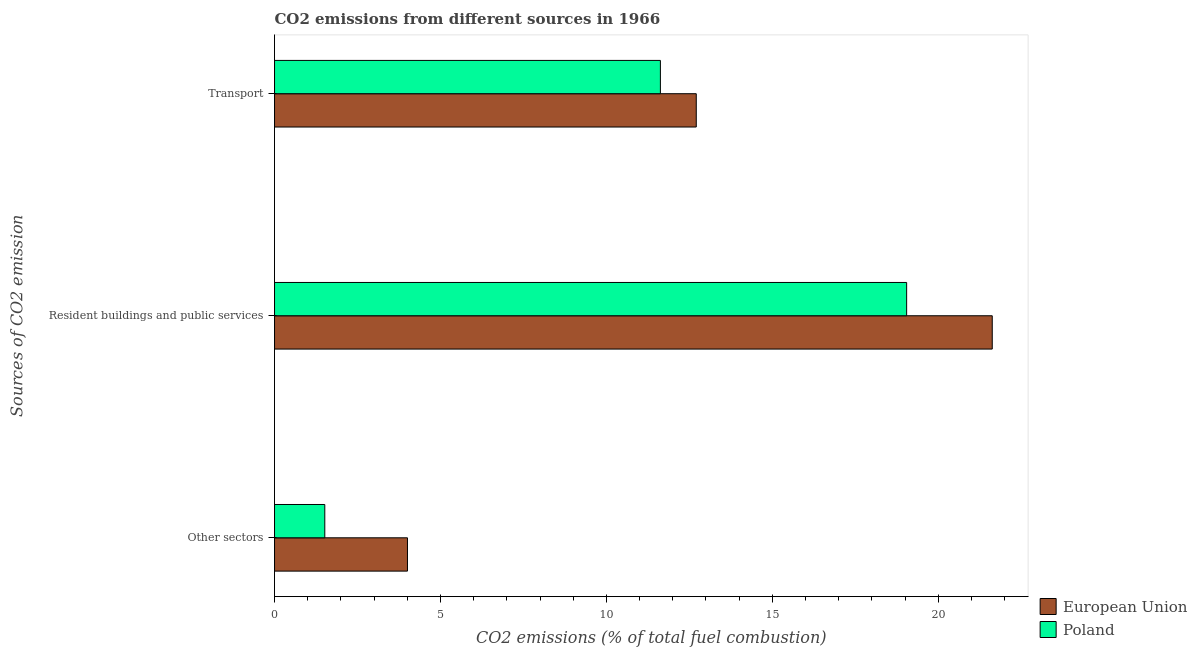How many different coloured bars are there?
Give a very brief answer. 2. Are the number of bars per tick equal to the number of legend labels?
Your response must be concise. Yes. Are the number of bars on each tick of the Y-axis equal?
Keep it short and to the point. Yes. What is the label of the 2nd group of bars from the top?
Your answer should be compact. Resident buildings and public services. What is the percentage of co2 emissions from resident buildings and public services in Poland?
Your answer should be compact. 19.05. Across all countries, what is the maximum percentage of co2 emissions from resident buildings and public services?
Make the answer very short. 21.63. Across all countries, what is the minimum percentage of co2 emissions from transport?
Offer a terse response. 11.63. In which country was the percentage of co2 emissions from transport minimum?
Your response must be concise. Poland. What is the total percentage of co2 emissions from resident buildings and public services in the graph?
Give a very brief answer. 40.67. What is the difference between the percentage of co2 emissions from other sectors in Poland and that in European Union?
Your answer should be very brief. -2.49. What is the difference between the percentage of co2 emissions from resident buildings and public services in Poland and the percentage of co2 emissions from transport in European Union?
Your response must be concise. 6.34. What is the average percentage of co2 emissions from other sectors per country?
Keep it short and to the point. 2.76. What is the difference between the percentage of co2 emissions from other sectors and percentage of co2 emissions from transport in European Union?
Provide a short and direct response. -8.7. In how many countries, is the percentage of co2 emissions from transport greater than 14 %?
Your response must be concise. 0. What is the ratio of the percentage of co2 emissions from other sectors in Poland to that in European Union?
Provide a short and direct response. 0.38. Is the percentage of co2 emissions from other sectors in European Union less than that in Poland?
Ensure brevity in your answer.  No. What is the difference between the highest and the second highest percentage of co2 emissions from other sectors?
Offer a very short reply. 2.49. What is the difference between the highest and the lowest percentage of co2 emissions from other sectors?
Offer a terse response. 2.49. Is the sum of the percentage of co2 emissions from resident buildings and public services in Poland and European Union greater than the maximum percentage of co2 emissions from other sectors across all countries?
Offer a terse response. Yes. What does the 1st bar from the top in Other sectors represents?
Provide a short and direct response. Poland. What does the 1st bar from the bottom in Resident buildings and public services represents?
Ensure brevity in your answer.  European Union. Are all the bars in the graph horizontal?
Provide a short and direct response. Yes. How many countries are there in the graph?
Keep it short and to the point. 2. Are the values on the major ticks of X-axis written in scientific E-notation?
Offer a terse response. No. Does the graph contain any zero values?
Your answer should be very brief. No. Does the graph contain grids?
Your answer should be very brief. No. How many legend labels are there?
Your response must be concise. 2. What is the title of the graph?
Offer a very short reply. CO2 emissions from different sources in 1966. Does "Czech Republic" appear as one of the legend labels in the graph?
Provide a succinct answer. No. What is the label or title of the X-axis?
Offer a very short reply. CO2 emissions (% of total fuel combustion). What is the label or title of the Y-axis?
Offer a very short reply. Sources of CO2 emission. What is the CO2 emissions (% of total fuel combustion) in European Union in Other sectors?
Provide a short and direct response. 4.01. What is the CO2 emissions (% of total fuel combustion) in Poland in Other sectors?
Offer a terse response. 1.51. What is the CO2 emissions (% of total fuel combustion) in European Union in Resident buildings and public services?
Keep it short and to the point. 21.63. What is the CO2 emissions (% of total fuel combustion) of Poland in Resident buildings and public services?
Your answer should be very brief. 19.05. What is the CO2 emissions (% of total fuel combustion) in European Union in Transport?
Your answer should be compact. 12.71. What is the CO2 emissions (% of total fuel combustion) in Poland in Transport?
Provide a short and direct response. 11.63. Across all Sources of CO2 emission, what is the maximum CO2 emissions (% of total fuel combustion) of European Union?
Give a very brief answer. 21.63. Across all Sources of CO2 emission, what is the maximum CO2 emissions (% of total fuel combustion) in Poland?
Provide a short and direct response. 19.05. Across all Sources of CO2 emission, what is the minimum CO2 emissions (% of total fuel combustion) of European Union?
Offer a terse response. 4.01. Across all Sources of CO2 emission, what is the minimum CO2 emissions (% of total fuel combustion) of Poland?
Provide a short and direct response. 1.51. What is the total CO2 emissions (% of total fuel combustion) in European Union in the graph?
Your answer should be very brief. 38.34. What is the total CO2 emissions (% of total fuel combustion) in Poland in the graph?
Your answer should be compact. 32.19. What is the difference between the CO2 emissions (% of total fuel combustion) in European Union in Other sectors and that in Resident buildings and public services?
Offer a terse response. -17.62. What is the difference between the CO2 emissions (% of total fuel combustion) of Poland in Other sectors and that in Resident buildings and public services?
Offer a terse response. -17.53. What is the difference between the CO2 emissions (% of total fuel combustion) in European Union in Other sectors and that in Transport?
Make the answer very short. -8.7. What is the difference between the CO2 emissions (% of total fuel combustion) of Poland in Other sectors and that in Transport?
Provide a short and direct response. -10.11. What is the difference between the CO2 emissions (% of total fuel combustion) of European Union in Resident buildings and public services and that in Transport?
Provide a short and direct response. 8.92. What is the difference between the CO2 emissions (% of total fuel combustion) of Poland in Resident buildings and public services and that in Transport?
Your answer should be compact. 7.42. What is the difference between the CO2 emissions (% of total fuel combustion) of European Union in Other sectors and the CO2 emissions (% of total fuel combustion) of Poland in Resident buildings and public services?
Offer a very short reply. -15.04. What is the difference between the CO2 emissions (% of total fuel combustion) in European Union in Other sectors and the CO2 emissions (% of total fuel combustion) in Poland in Transport?
Ensure brevity in your answer.  -7.62. What is the difference between the CO2 emissions (% of total fuel combustion) in European Union in Resident buildings and public services and the CO2 emissions (% of total fuel combustion) in Poland in Transport?
Keep it short and to the point. 10. What is the average CO2 emissions (% of total fuel combustion) in European Union per Sources of CO2 emission?
Ensure brevity in your answer.  12.78. What is the average CO2 emissions (% of total fuel combustion) of Poland per Sources of CO2 emission?
Make the answer very short. 10.73. What is the difference between the CO2 emissions (% of total fuel combustion) of European Union and CO2 emissions (% of total fuel combustion) of Poland in Other sectors?
Provide a succinct answer. 2.49. What is the difference between the CO2 emissions (% of total fuel combustion) of European Union and CO2 emissions (% of total fuel combustion) of Poland in Resident buildings and public services?
Your answer should be compact. 2.58. What is the difference between the CO2 emissions (% of total fuel combustion) of European Union and CO2 emissions (% of total fuel combustion) of Poland in Transport?
Your response must be concise. 1.08. What is the ratio of the CO2 emissions (% of total fuel combustion) of European Union in Other sectors to that in Resident buildings and public services?
Ensure brevity in your answer.  0.19. What is the ratio of the CO2 emissions (% of total fuel combustion) of Poland in Other sectors to that in Resident buildings and public services?
Keep it short and to the point. 0.08. What is the ratio of the CO2 emissions (% of total fuel combustion) of European Union in Other sectors to that in Transport?
Keep it short and to the point. 0.32. What is the ratio of the CO2 emissions (% of total fuel combustion) of Poland in Other sectors to that in Transport?
Keep it short and to the point. 0.13. What is the ratio of the CO2 emissions (% of total fuel combustion) of European Union in Resident buildings and public services to that in Transport?
Offer a terse response. 1.7. What is the ratio of the CO2 emissions (% of total fuel combustion) in Poland in Resident buildings and public services to that in Transport?
Provide a short and direct response. 1.64. What is the difference between the highest and the second highest CO2 emissions (% of total fuel combustion) in European Union?
Your answer should be compact. 8.92. What is the difference between the highest and the second highest CO2 emissions (% of total fuel combustion) in Poland?
Make the answer very short. 7.42. What is the difference between the highest and the lowest CO2 emissions (% of total fuel combustion) of European Union?
Make the answer very short. 17.62. What is the difference between the highest and the lowest CO2 emissions (% of total fuel combustion) in Poland?
Keep it short and to the point. 17.53. 